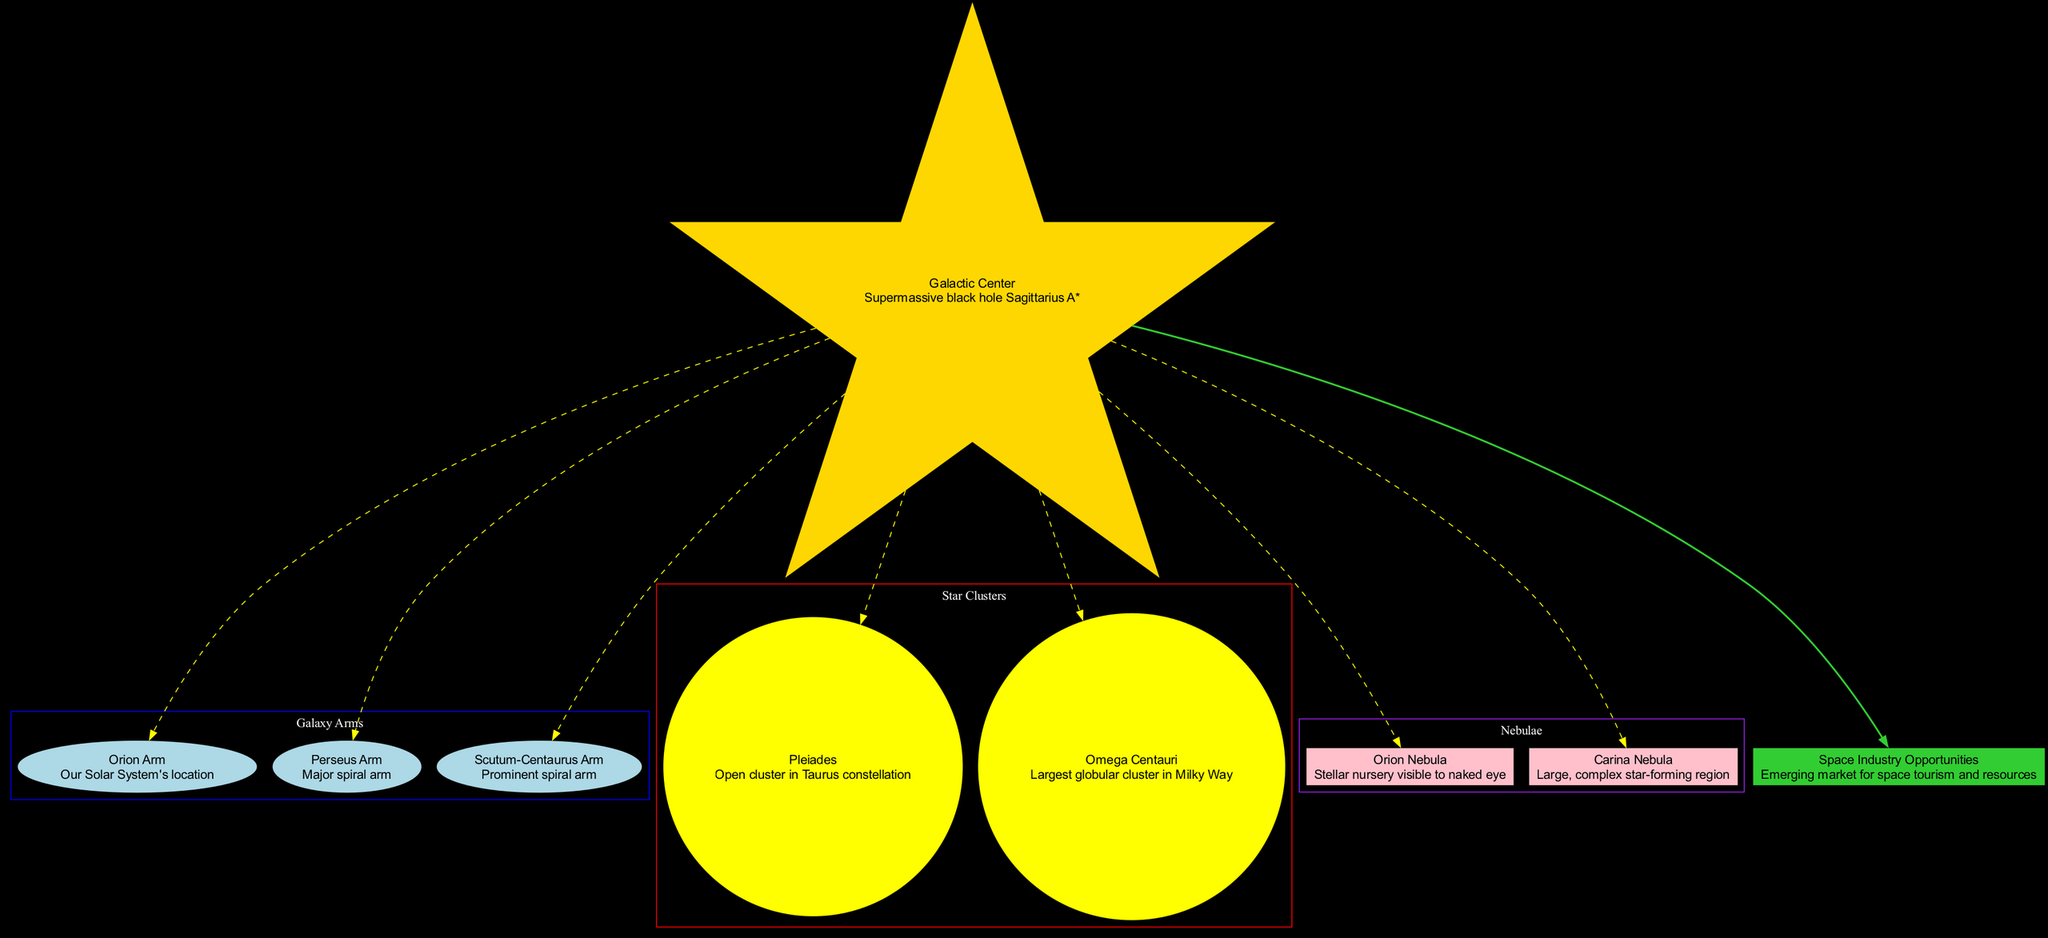What is the name of the supermassive black hole at the Galactic Center? The diagram indicates that the center node is labeled "Galactic Center," and its description specifies "Supermassive black hole Sagittarius A*." Therefore, by directly referring to the description, we determine the answer.
Answer: Sagittarius A* How many major arms are highlighted in the Milky Way diagram? The diagram features three major arms: Orion Arm, Perseus Arm, and Scutum-Centaurus Arm. By counting the listed arm names, we find there are three arms present.
Answer: 3 Which star cluster is located in the Taurus constellation? Among the star clusters shown in the diagram, the "Pleiades" is mentioned to be located in the Taurus constellation according to its description directly attached to the node.
Answer: Pleiades What is the shape of the nodes representing nebulae? The diagram designates the nebulae with nodes shaped like "clouds," as indicated in the node attributes of the nebula section. Thus, this shape corresponds to the nebulae as shown in the diagram.
Answer: cloud Which nebula is described as a stellar nursery visible to the naked eye? The diagram lists the "Orion Nebula" in the nebula section, alongside its description that explicitly states it is a "stellar nursery visible to naked eye." This allows us to identify the mentioned nebula correctly.
Answer: Orion Nebula What color code represents the star cluster section in the diagram? The color for the "Star Clusters" subgraph in the diagram is indicated to be red, as per the attributed color setting within that specific section of the diagram. Therefore, we conclude the star cluster color.
Answer: red Which arm of the Milky Way contains our Solar System? According to the description attached to the "Orion Arm" node, it explicitly states our Solar System's location is found in this arm. Therefore, we can directly identify the correct arm based on the provided information.
Answer: Orion Arm What aspect of the business is highlighted in relation to space? The diagram emphasizes "Space Industry Opportunities" as the name of the business relevance, with a description focusing on "emerging market for space tourism and resources." By referring to this node, we can identify the key business aspect presented.
Answer: Space Industry Opportunities 